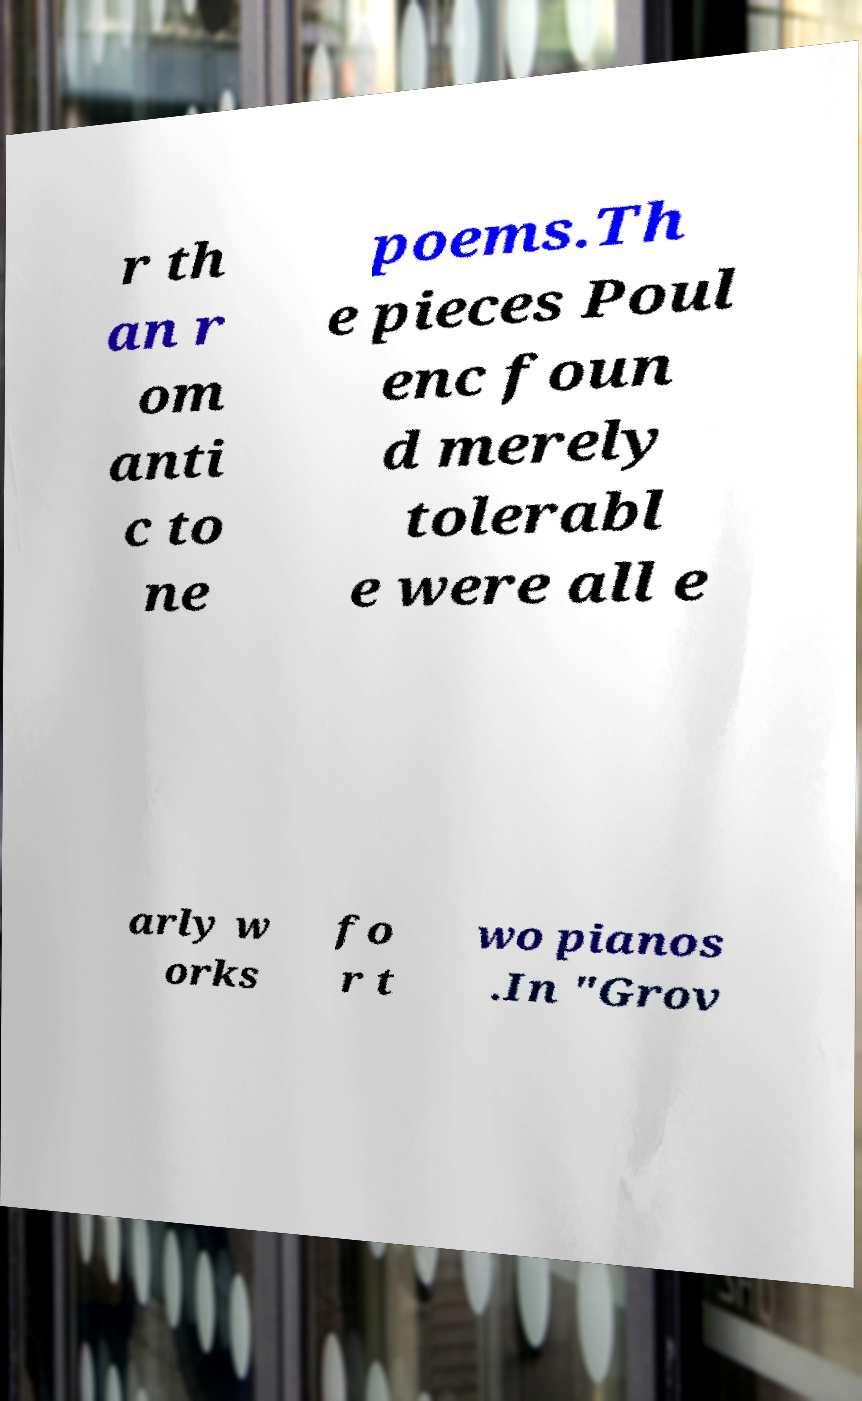There's text embedded in this image that I need extracted. Can you transcribe it verbatim? r th an r om anti c to ne poems.Th e pieces Poul enc foun d merely tolerabl e were all e arly w orks fo r t wo pianos .In "Grov 